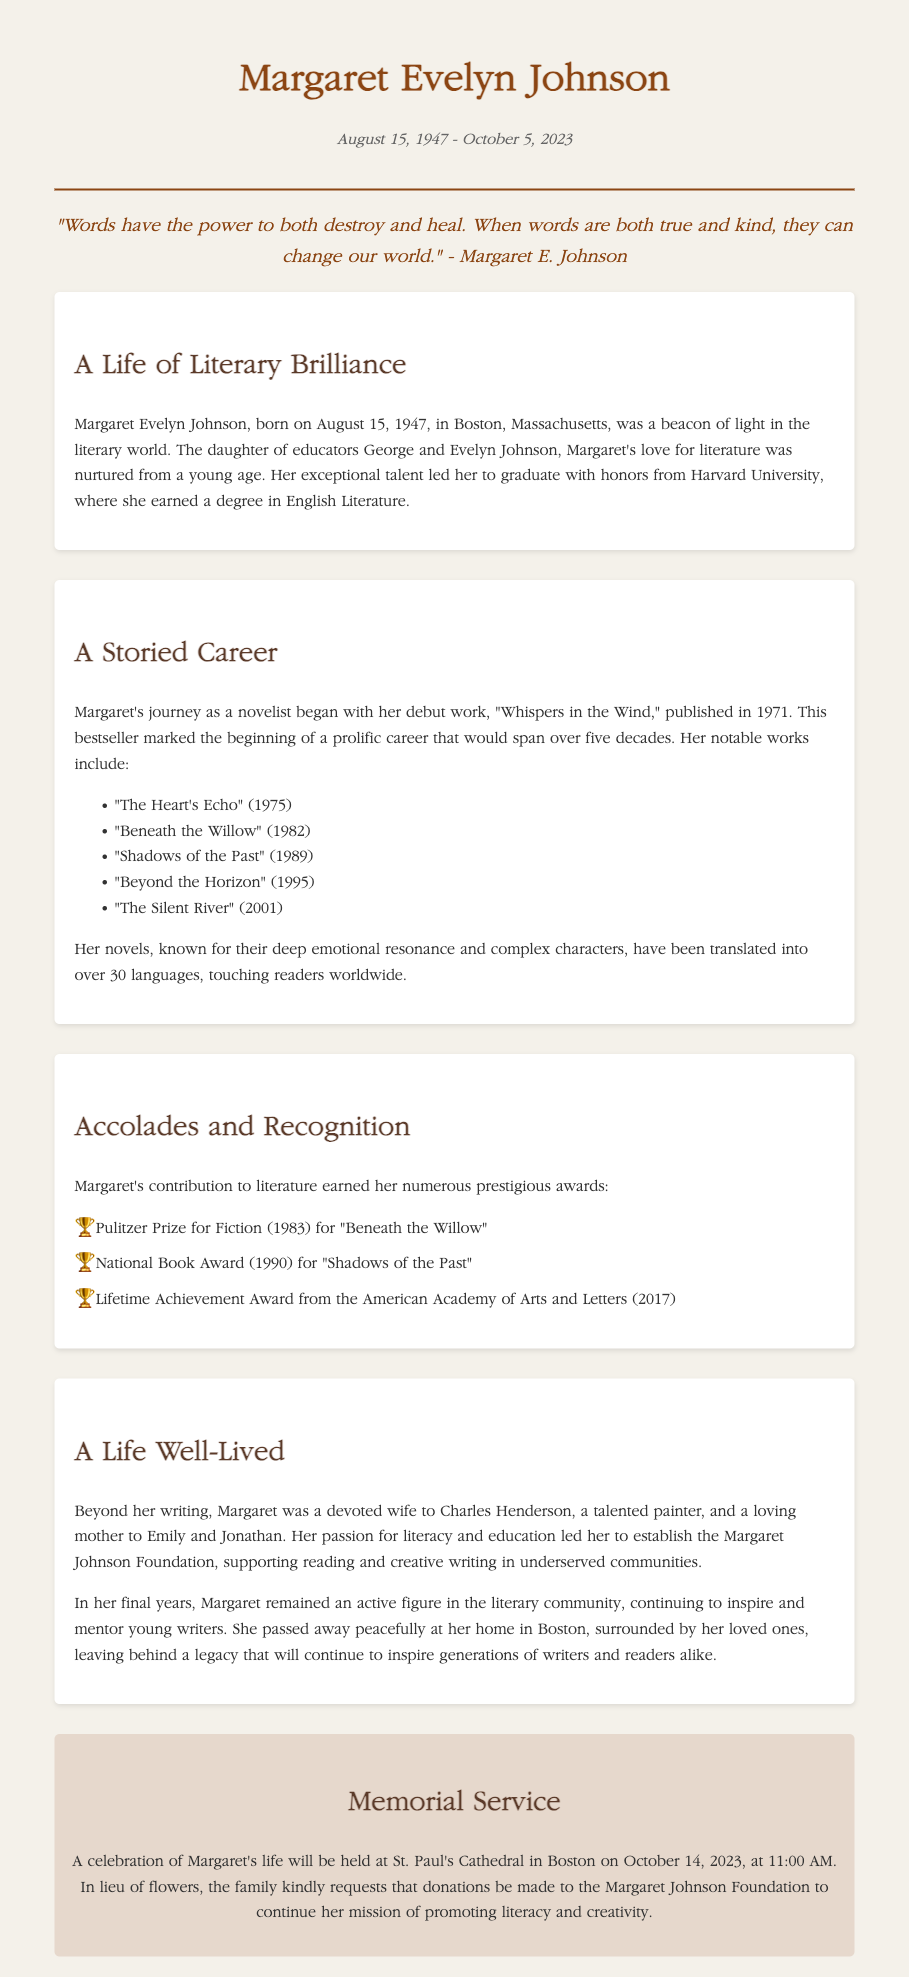What date was Margaret Evelyn Johnson born? The document states that Margaret Evelyn Johnson was born on August 15, 1947.
Answer: August 15, 1947 What was Margaret's first published novel? According to the document, her debut work was "Whispers in the Wind," published in 1971.
Answer: Whispers in the Wind Which award did Margaret receive for "Beneath the Willow"? The document mentions that she won the Pulitzer Prize for Fiction (1983) for "Beneath the Willow."
Answer: Pulitzer Prize for Fiction How many children did Margaret have? The document states that she was a loving mother to Emily and Jonathan, indicating she had two children.
Answer: Two What was Margaret's profession apart from being a novelist? The document describes her as a devoted wife and indicates her involvement in establishing the Margaret Johnson Foundation.
Answer: Foundation founder What is the date and time of the memorial service? The memorial service is scheduled for October 14, 2023, at 11:00 AM, according to the document.
Answer: October 14, 2023, at 11:00 AM What legacy did Margaret leave behind? The document mentions that she left a legacy that will continue to inspire generations of writers and readers.
Answer: Inspire generations of writers and readers What significant role did Margaret have in her community? The document states that she established the Margaret Johnson Foundation to support literacy and creative writing in underserved communities.
Answer: Literacy support 